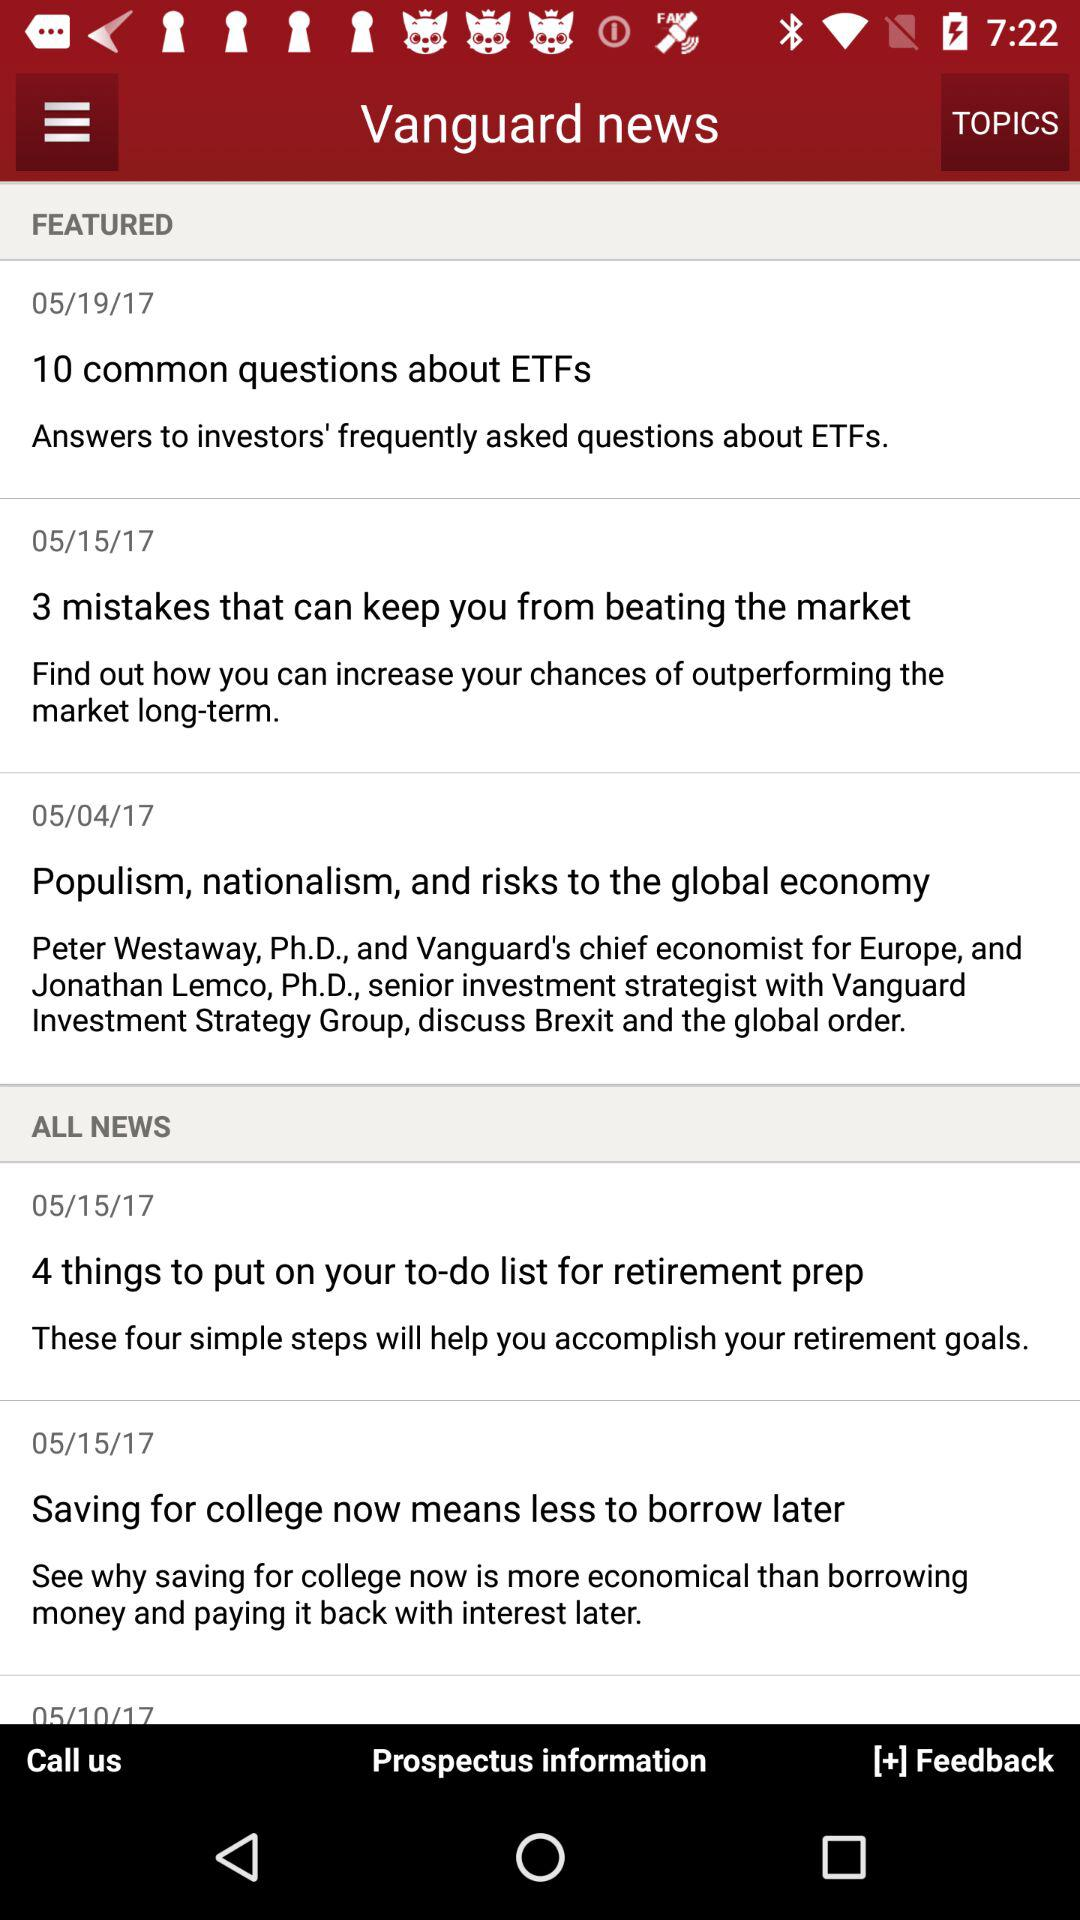Which news was published on 05/19/17? The news that was published on 05/19/17 was "10 common questions about ETFs". 